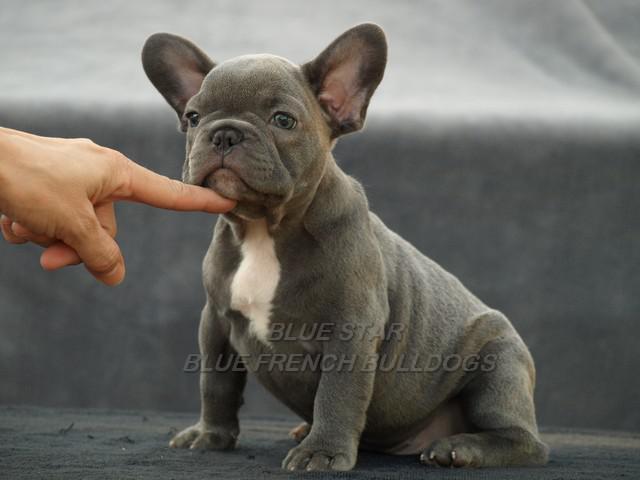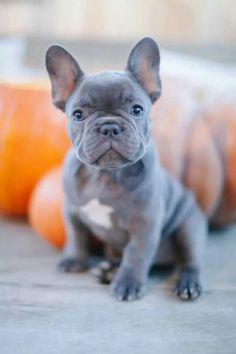The first image is the image on the left, the second image is the image on the right. For the images displayed, is the sentence "The dog in the image on the right is standing up on all four feet." factually correct? Answer yes or no. No. The first image is the image on the left, the second image is the image on the right. For the images shown, is this caption "The left image shows a grey bulldog in front of a gray background, and the right image shows a grey bulldog sitting in front of something bright orange." true? Answer yes or no. Yes. 